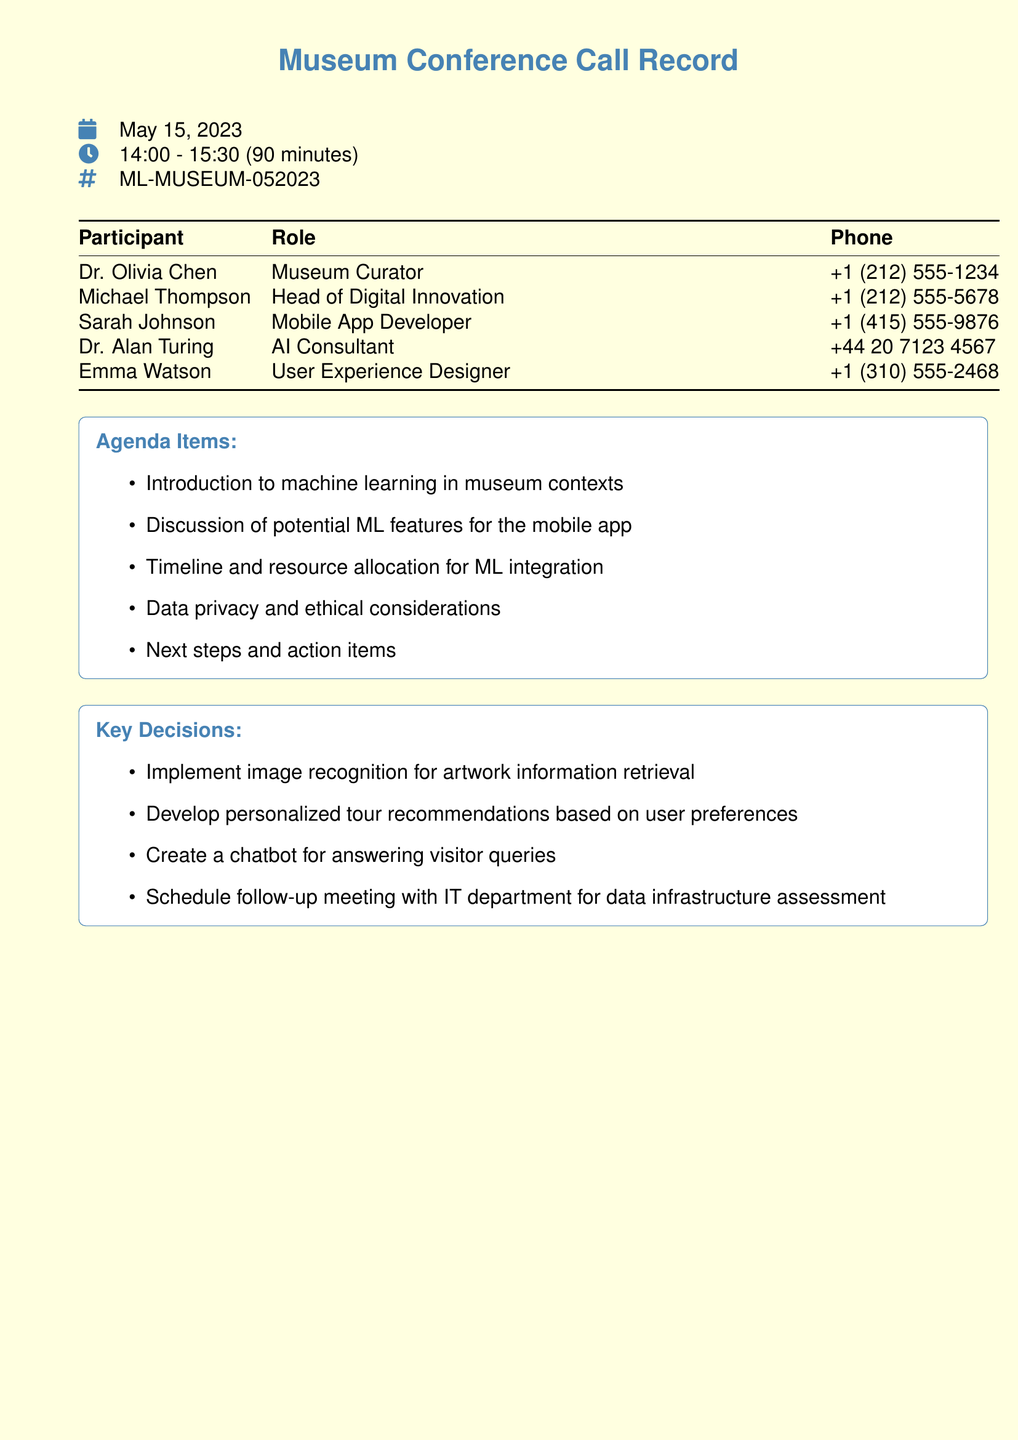what is the date of the conference call? The date is specifically mentioned in the document's header.
Answer: May 15, 2023 how long was the conference call? The duration is provided in the time section of the document.
Answer: 90 minutes who is the museum curator? The document lists participants along with their roles.
Answer: Dr. Olivia Chen what is the phone number of the Head of Digital Innovation? The phone number for each participant is included in the table.
Answer: +1 (212) 555-5678 what was one of the agenda items discussed? The agenda items are clearly listed, and this question refers to that list.
Answer: Introduction to machine learning in museum contexts how many participants were on the call? The document presents a table with all the listed participants.
Answer: 5 what decision was made regarding personalized recommendations? The document outlines key decisions that were made during the call.
Answer: Develop personalized tour recommendations based on user preferences who should the follow-up meeting be scheduled with? The key decisions included action items, including follow-up meeting details.
Answer: IT department 